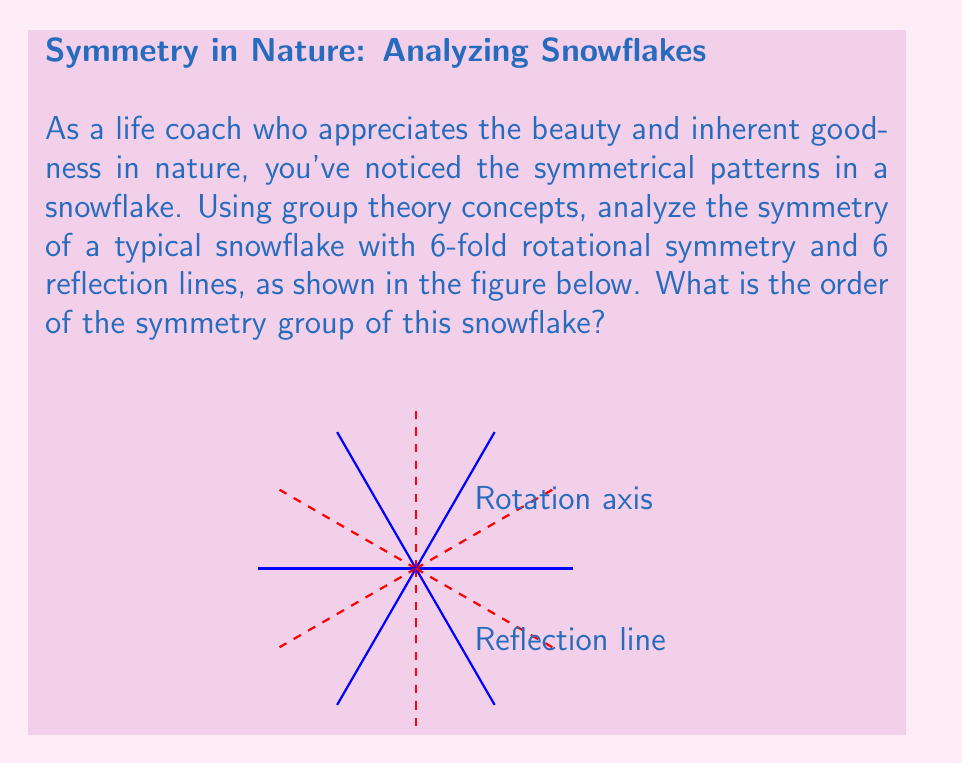Help me with this question. To analyze the symmetry of the snowflake using group theory, we follow these steps:

1) Identify the symmetry operations:
   - Rotations: The snowflake has 6-fold rotational symmetry, meaning it can be rotated by multiples of 60° (or $\frac{\pi}{3}$ radians) and remain unchanged.
   - Reflections: There are 6 lines of reflection symmetry.

2) Count the distinct symmetry operations:
   - Rotations: There are 6 rotations (including the identity rotation):
     $$\{0°, 60°, 120°, 180°, 240°, 300°\}$$
   - Reflections: There are 6 reflections, one across each line of symmetry.

3) Apply the principle that the order of a group is the number of its elements:
   - Each symmetry operation corresponds to a unique element in the symmetry group.
   - The total number of elements is the sum of rotations and reflections.

4) Calculate the order of the group:
   $$\text{Order} = \text{Number of rotations} + \text{Number of reflections}$$
   $$\text{Order} = 6 + 6 = 12$$

5) Identify the group:
   This symmetry group is known as the dihedral group $D_6$, which has order 12.

The order of the symmetry group represents the total number of ways the snowflake can be transformed while maintaining its appearance, reflecting the intricate balance and harmony in nature's design.
Answer: 12 